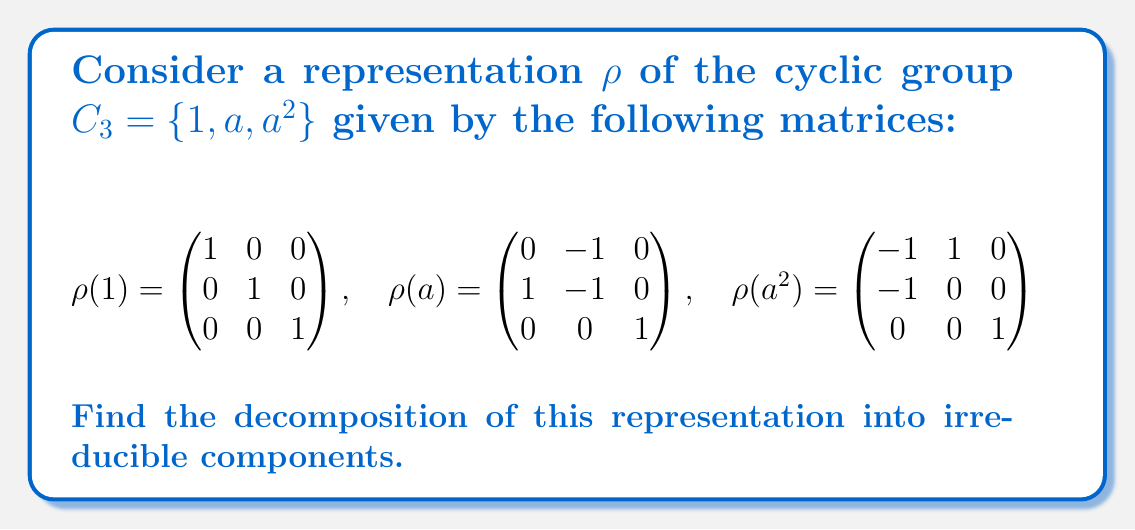Show me your answer to this math problem. To decompose this representation into irreducible components, we'll follow these steps:

1) First, recall that for $C_3$, there are three irreducible representations:
   - The trivial representation: $\chi_1(1) = \chi_1(a) = \chi_1(a^2) = 1$
   - Two 1-dimensional representations: 
     $\chi_2(1) = 1, \chi_2(a) = \omega, \chi_2(a^2) = \omega^2$
     $\chi_3(1) = 1, \chi_3(a) = \omega^2, \chi_3(a^2) = \omega$
   where $\omega = e^{2\pi i/3} = -\frac{1}{2} + i\frac{\sqrt{3}}{2}$

2) Calculate the character of our given representation $\rho$:
   $\chi_\rho(1) = 3$ (trace of identity matrix)
   $\chi_\rho(a) = 0$ (trace of $\rho(a)$)
   $\chi_\rho(a^2) = 0$ (trace of $\rho(a^2)$)

3) Use the inner product formula to find the multiplicity of each irreducible representation:
   $m_i = \frac{1}{|G|}\sum_{g \in G} \chi_\rho(g)\overline{\chi_i(g)}$

   For $\chi_1$: $m_1 = \frac{1}{3}(3 \cdot 1 + 0 \cdot 1 + 0 \cdot 1) = 1$
   For $\chi_2$: $m_2 = \frac{1}{3}(3 \cdot 1 + 0 \cdot \omega^2 + 0 \cdot \omega) = 1$
   For $\chi_3$: $m_3 = \frac{1}{3}(3 \cdot 1 + 0 \cdot \omega + 0 \cdot \omega^2) = 1$

4) Therefore, the decomposition is:
   $\rho = \chi_1 \oplus \chi_2 \oplus \chi_3$

This means our 3-dimensional representation decomposes into the direct sum of all three 1-dimensional irreducible representations of $C_3$.
Answer: $\rho = \chi_1 \oplus \chi_2 \oplus \chi_3$ 